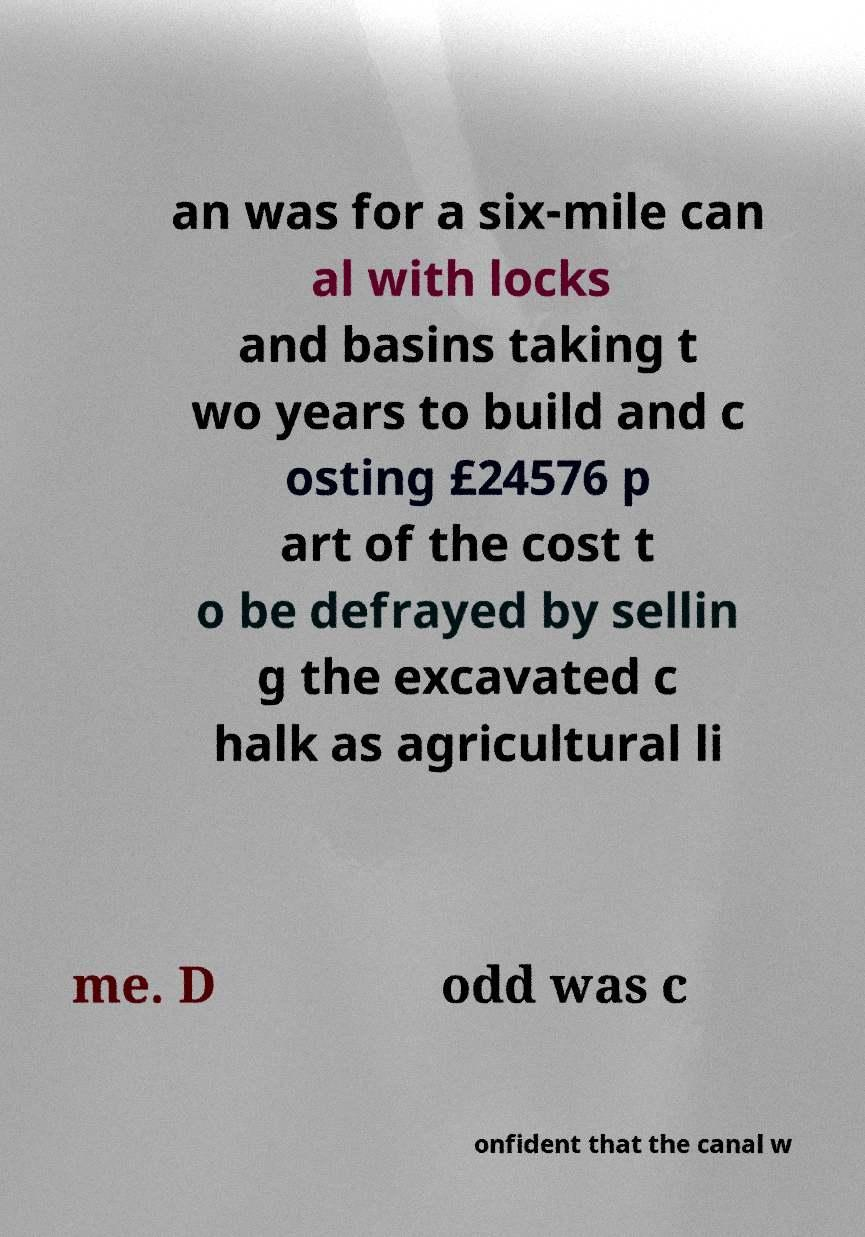For documentation purposes, I need the text within this image transcribed. Could you provide that? an was for a six-mile can al with locks and basins taking t wo years to build and c osting £24576 p art of the cost t o be defrayed by sellin g the excavated c halk as agricultural li me. D odd was c onfident that the canal w 